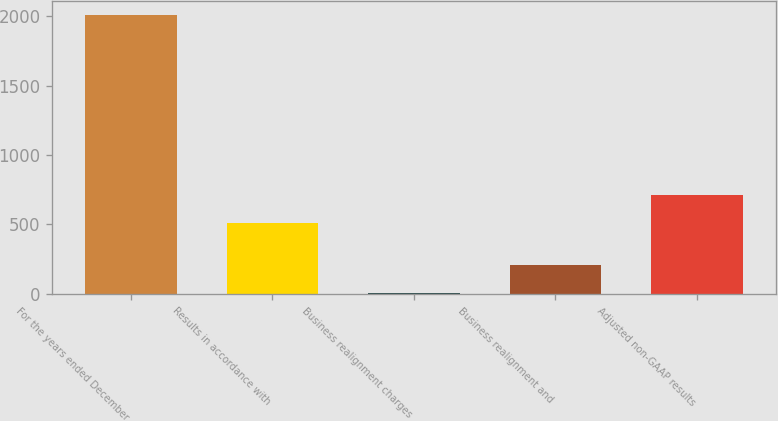Convert chart. <chart><loc_0><loc_0><loc_500><loc_500><bar_chart><fcel>For the years ended December<fcel>Results in accordance with<fcel>Business realignment charges<fcel>Business realignment and<fcel>Adjusted non-GAAP results<nl><fcel>2010<fcel>509.8<fcel>8.4<fcel>208.56<fcel>709.96<nl></chart> 